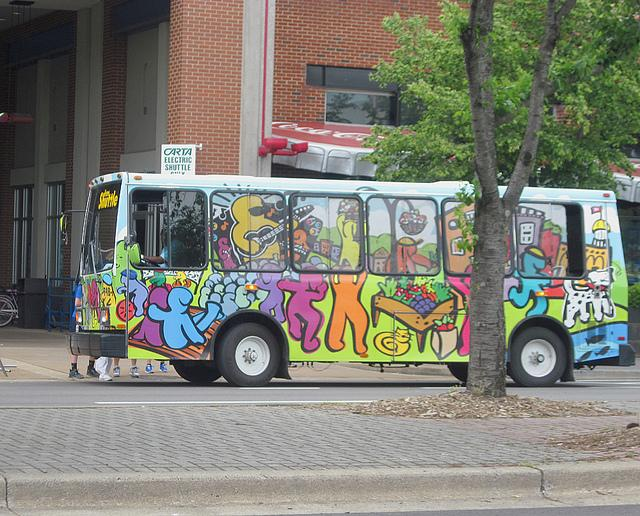What is the profession of the man seen on the bus? Please explain your reasoning. driver. There is only one person visible on the bus and they are in the driver's seat and are in contact with the steering wheel. someone sitting in the driver's seat and driving the bus is likely a professional. 